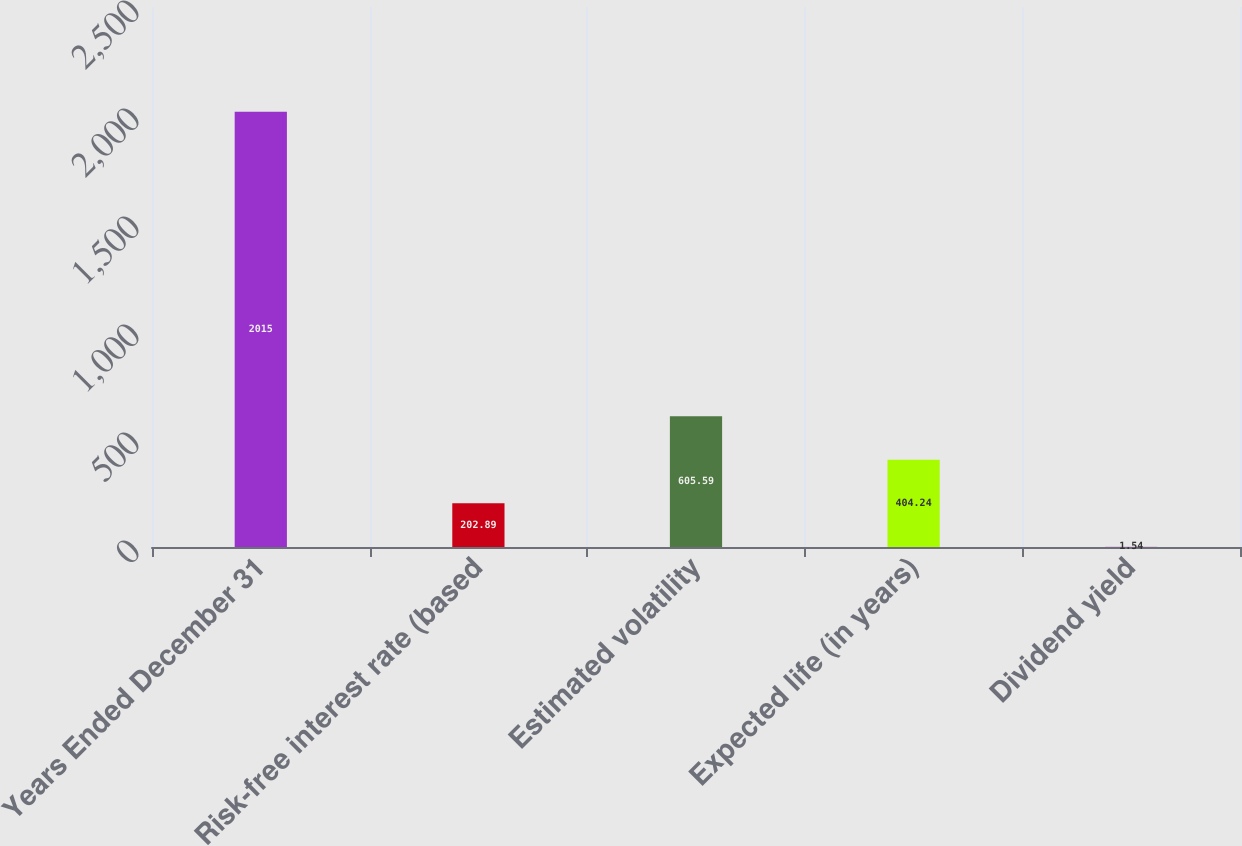Convert chart. <chart><loc_0><loc_0><loc_500><loc_500><bar_chart><fcel>Years Ended December 31<fcel>Risk-free interest rate (based<fcel>Estimated volatility<fcel>Expected life (in years)<fcel>Dividend yield<nl><fcel>2015<fcel>202.89<fcel>605.59<fcel>404.24<fcel>1.54<nl></chart> 